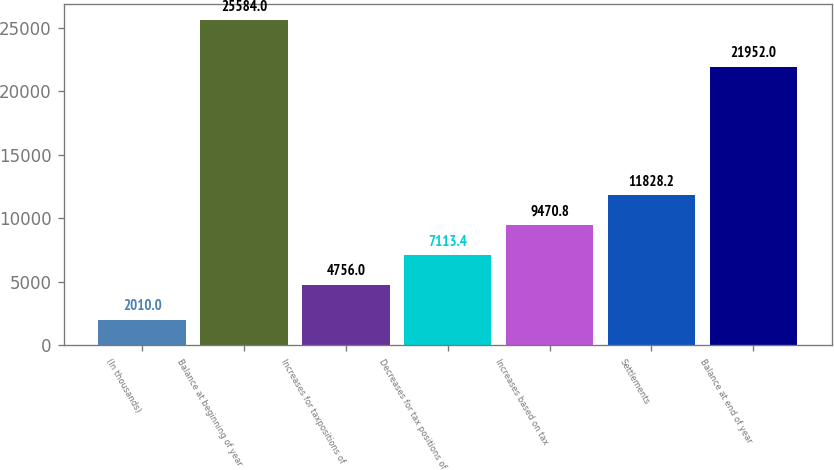<chart> <loc_0><loc_0><loc_500><loc_500><bar_chart><fcel>(In thousands)<fcel>Balance at beginning of year<fcel>Increases for taxpositions of<fcel>Decreases for tax positions of<fcel>Increases based on tax<fcel>Settlements<fcel>Balance at end of year<nl><fcel>2010<fcel>25584<fcel>4756<fcel>7113.4<fcel>9470.8<fcel>11828.2<fcel>21952<nl></chart> 